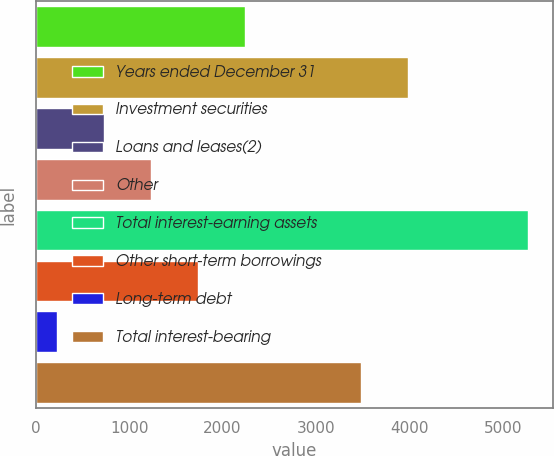Convert chart to OTSL. <chart><loc_0><loc_0><loc_500><loc_500><bar_chart><fcel>Years ended December 31<fcel>Investment securities<fcel>Loans and leases(2)<fcel>Other<fcel>Total interest-earning assets<fcel>Other short-term borrowings<fcel>Long-term debt<fcel>Total interest-bearing<nl><fcel>2243<fcel>3986.5<fcel>729.5<fcel>1234<fcel>5270<fcel>1738.5<fcel>225<fcel>3482<nl></chart> 